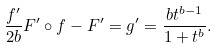Convert formula to latex. <formula><loc_0><loc_0><loc_500><loc_500>\frac { f ^ { \prime } } { 2 b } F ^ { \prime } \circ f - F ^ { \prime } = g ^ { \prime } = \frac { b t ^ { b - 1 } } { 1 + t ^ { b } } .</formula> 